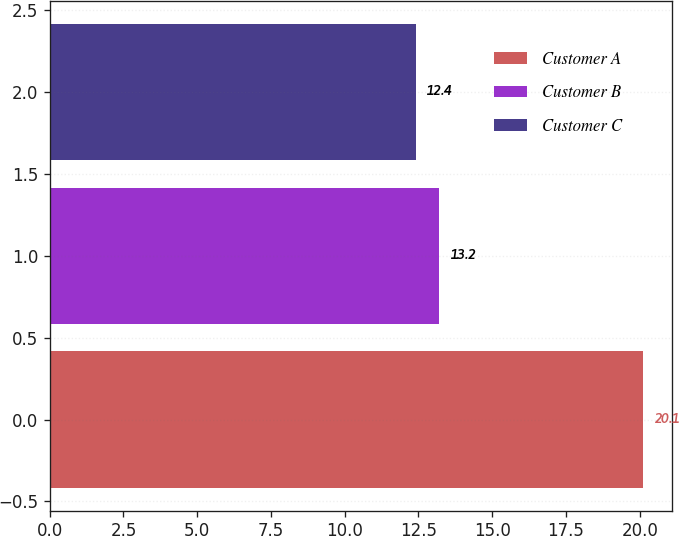Convert chart. <chart><loc_0><loc_0><loc_500><loc_500><bar_chart><fcel>Customer A<fcel>Customer B<fcel>Customer C<nl><fcel>20.1<fcel>13.2<fcel>12.4<nl></chart> 